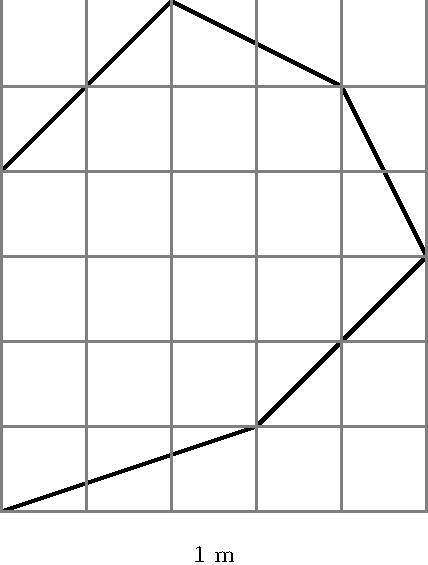As a florist preparing for a library event, you've been asked to estimate the area of an irregularly shaped garden plot for a new wildflower display. The plot is overlaid with a 1-meter grid as shown. Estimate the area of the garden plot in square meters. To estimate the area of the irregularly shaped garden plot, we can use the grid method. Here's how to approach it:

1. Count the number of whole squares within the garden plot. There are approximately 12 whole squares.

2. For partial squares, we need to estimate their contribution:
   - There are about 8 squares that are more than half filled.
   - There are about 6 squares that are less than half filled.

3. We can consider squares that are more than half filled as 1, and squares less than half filled as 0.5.

4. Calculate the total:
   $$ \text{Total squares} = 12 + (8 \times 1) + (6 \times 0.5) $$
   $$ = 12 + 8 + 3 = 23 $$

5. Since each square represents 1 square meter, the estimated area is 23 square meters.

This method provides a reasonable estimate for irregular shapes without requiring complex calculations.
Answer: 23 square meters 